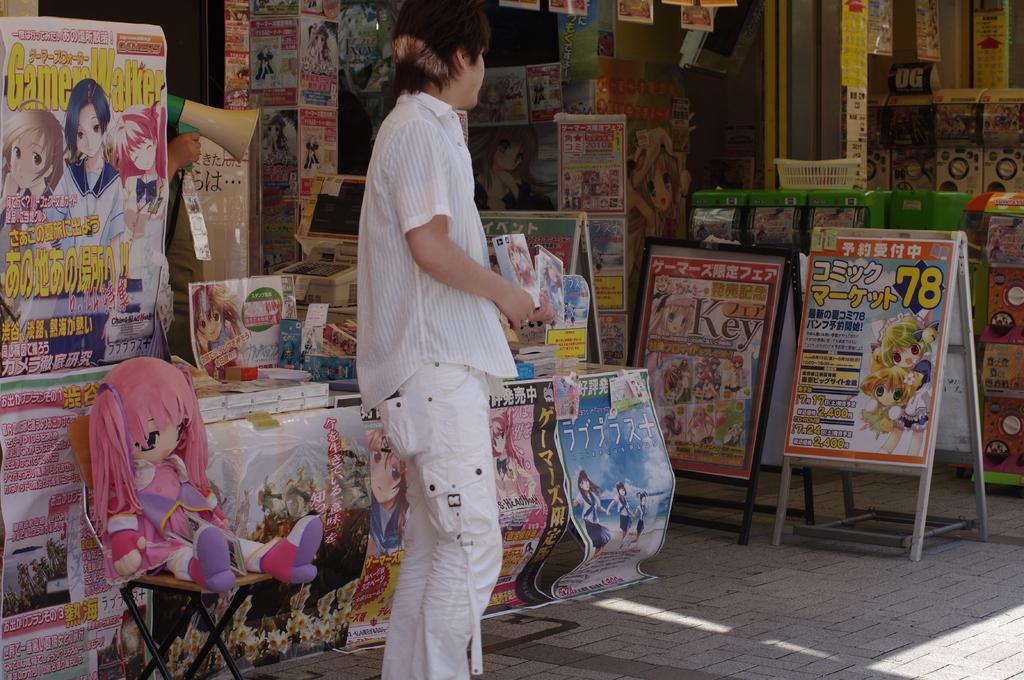Where is this store located?
Offer a very short reply. Unanswerable. What number is posted in yellow on the display on the right?
Keep it short and to the point. 78. 